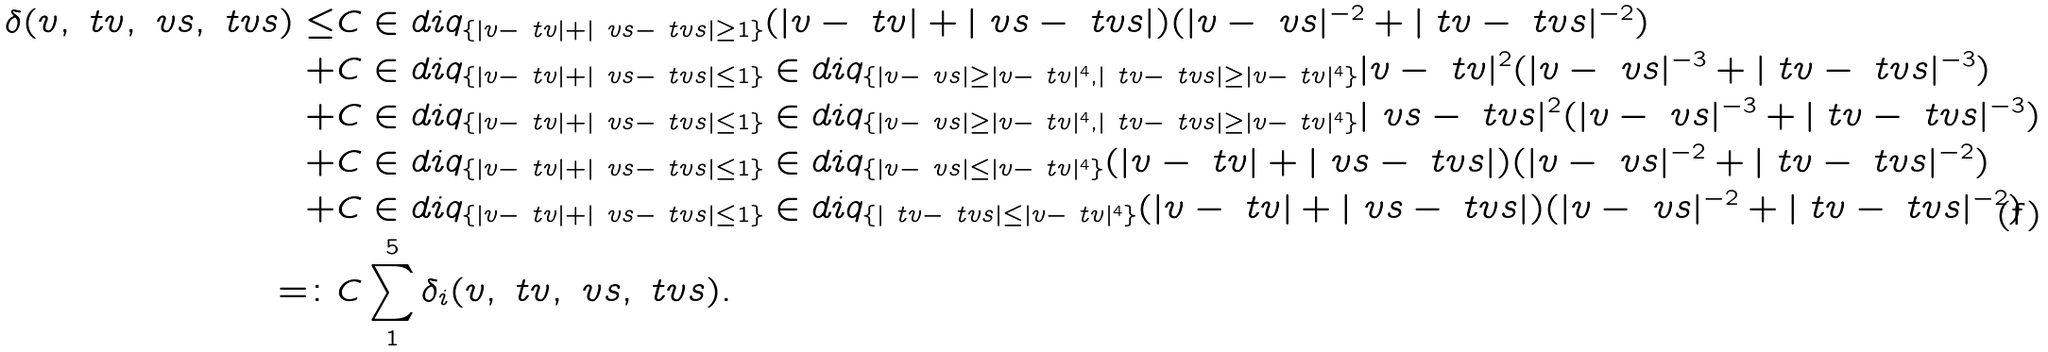Convert formula to latex. <formula><loc_0><loc_0><loc_500><loc_500>\delta ( v , \ t v , \ v s , \ t v s ) \leq & C \in d i q _ { \{ | v - \ t v | + | \ v s - \ t v s | \geq 1 \} } ( | v - \ t v | + | \ v s - \ t v s | ) ( | v - \ v s | ^ { - 2 } + | \ t v - \ t v s | ^ { - 2 } ) \\ + & C \in d i q _ { \{ | v - \ t v | + | \ v s - \ t v s | \leq 1 \} } \in d i q _ { \{ | v - \ v s | \geq | v - \ t v | ^ { 4 } , | \ t v - \ t v s | \geq | v - \ t v | ^ { 4 } \} } | v - \ t v | ^ { 2 } ( | v - \ v s | ^ { - 3 } + | \ t v - \ t v s | ^ { - 3 } ) \\ + & C \in d i q _ { \{ | v - \ t v | + | \ v s - \ t v s | \leq 1 \} } \in d i q _ { \{ | v - \ v s | \geq | v - \ t v | ^ { 4 } , | \ t v - \ t v s | \geq | v - \ t v | ^ { 4 } \} } | \ v s - \ t v s | ^ { 2 } ( | v - \ v s | ^ { - 3 } + | \ t v - \ t v s | ^ { - 3 } ) \\ + & C \in d i q _ { \{ | v - \ t v | + | \ v s - \ t v s | \leq 1 \} } \in d i q _ { \{ | v - \ v s | \leq | v - \ t v | ^ { 4 } \} } ( | v - \ t v | + | \ v s - \ t v s | ) ( | v - \ v s | ^ { - 2 } + | \ t v - \ t v s | ^ { - 2 } ) \\ + & C \in d i q _ { \{ | v - \ t v | + | \ v s - \ t v s | \leq 1 \} } \in d i q _ { \{ | \ t v - \ t v s | \leq | v - \ t v | ^ { 4 } \} } ( | v - \ t v | + | \ v s - \ t v s | ) ( | v - \ v s | ^ { - 2 } + | \ t v - \ t v s | ^ { - 2 } ) \\ = \colon & C \sum _ { 1 } ^ { 5 } \delta _ { i } ( v , \ t v , \ v s , \ t v s ) .</formula> 